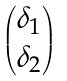Convert formula to latex. <formula><loc_0><loc_0><loc_500><loc_500>\begin{pmatrix} \delta _ { 1 } \\ \delta _ { 2 } \end{pmatrix}</formula> 